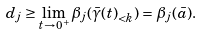Convert formula to latex. <formula><loc_0><loc_0><loc_500><loc_500>d _ { j } \geq \lim _ { t \to 0 ^ { + } } \beta _ { j } ( { \bar { \gamma } ( t ) } _ { < k } ) = \beta _ { j } ( \bar { a } ) .</formula> 